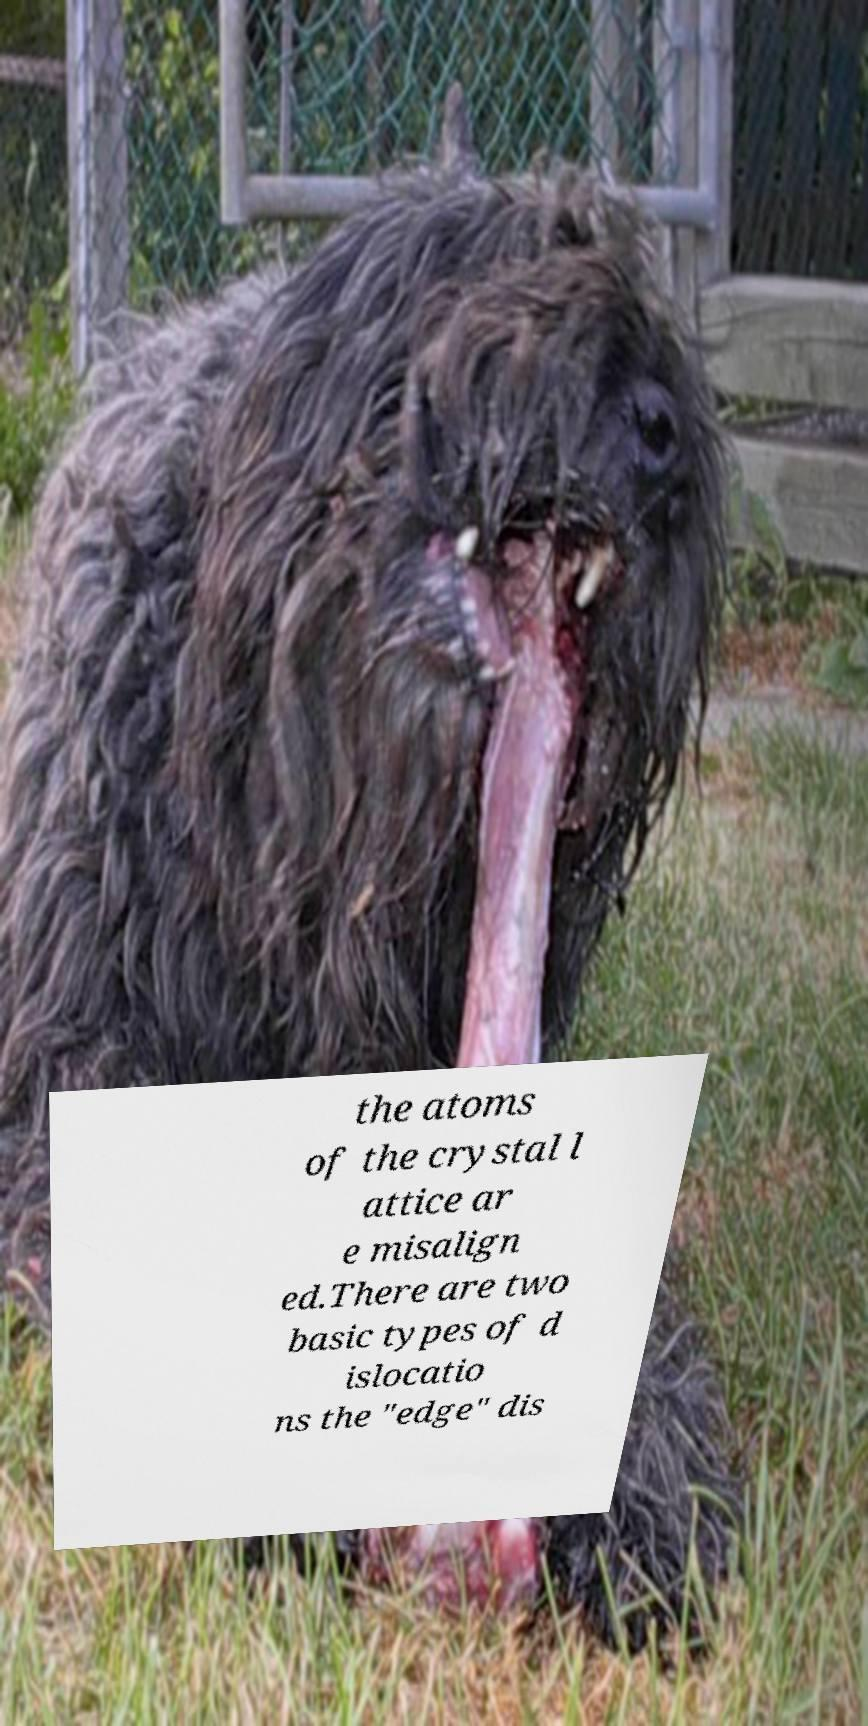Please read and relay the text visible in this image. What does it say? the atoms of the crystal l attice ar e misalign ed.There are two basic types of d islocatio ns the "edge" dis 